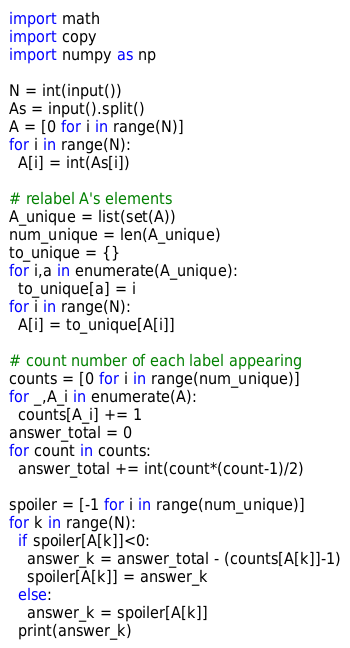<code> <loc_0><loc_0><loc_500><loc_500><_Python_>import math
import copy
import numpy as np

N = int(input())
As = input().split()
A = [0 for i in range(N)]
for i in range(N):
  A[i] = int(As[i])

# relabel A's elements
A_unique = list(set(A))
num_unique = len(A_unique)
to_unique = {}
for i,a in enumerate(A_unique):
  to_unique[a] = i
for i in range(N):
  A[i] = to_unique[A[i]]

# count number of each label appearing
counts = [0 for i in range(num_unique)]
for _,A_i in enumerate(A):
  counts[A_i] += 1
answer_total = 0
for count in counts:
  answer_total += int(count*(count-1)/2)

spoiler = [-1 for i in range(num_unique)]
for k in range(N):
  if spoiler[A[k]]<0:
    answer_k = answer_total - (counts[A[k]]-1)
    spoiler[A[k]] = answer_k
  else:
    answer_k = spoiler[A[k]]
  print(answer_k)
</code> 